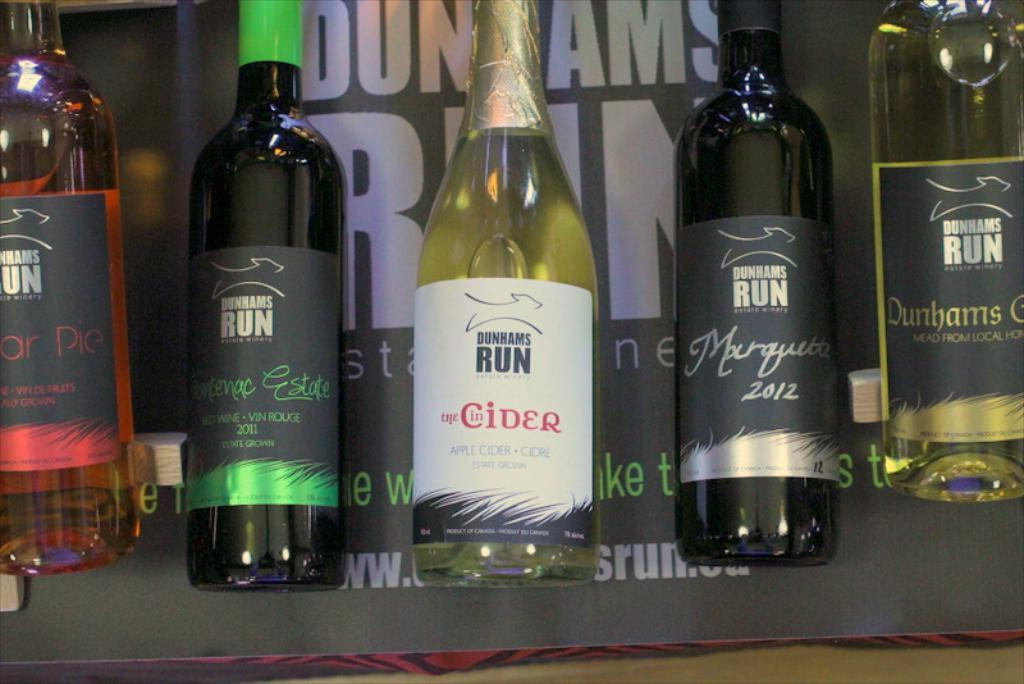<image>
Offer a succinct explanation of the picture presented. several bottles of Dunhams run alcohol are lined up 